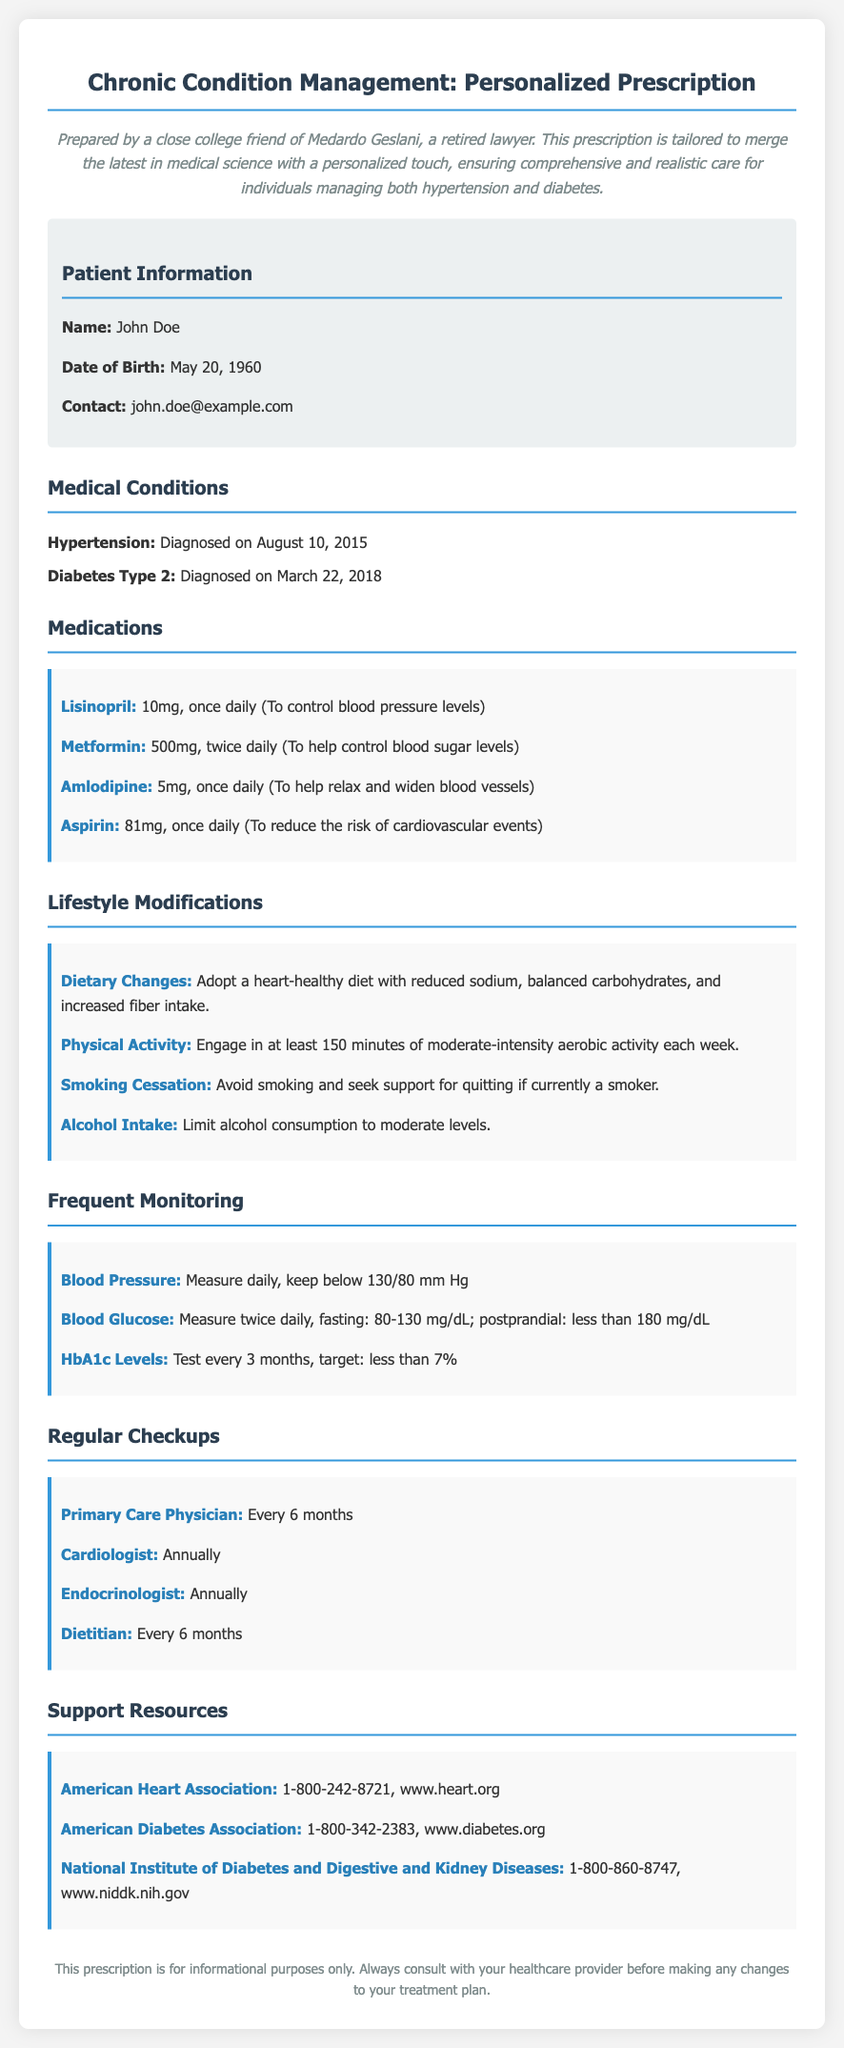What is the patient's name? The patient's name is listed at the beginning of the document in the patient information section.
Answer: John Doe What is the dosage of Lisinopril? The dosage of Lisinopril is specified under the medications section of the document.
Answer: 10mg, once daily When was the patient diagnosed with diabetes? The diagnosis date for diabetes is mentioned in the medical conditions section.
Answer: March 22, 2018 How often should the patient measure their blood glucose? The frequency for blood glucose measurement is noted in the frequent monitoring section.
Answer: Twice daily What is the target HbA1c level for the patient? The target HbA1c level can be found in the frequent monitoring section of the document.
Answer: Less than 7% What lifestyle change is recommended regarding alcohol? The document suggests a specific modification related to alcohol in the lifestyle modifications section.
Answer: Limit alcohol consumption to moderate levels How often should the patient see their primary care physician? The frequency of visits to the primary care physician is indicated in the regular checkups section.
Answer: Every 6 months Which organization can the patient contact for diabetes support? The document lists contact details for support resources, which can be found in the support resources section.
Answer: American Diabetes Association What is the phone number for the American Heart Association? The phone number for the American Heart Association is provided in the support resources section.
Answer: 1-800-242-8721 